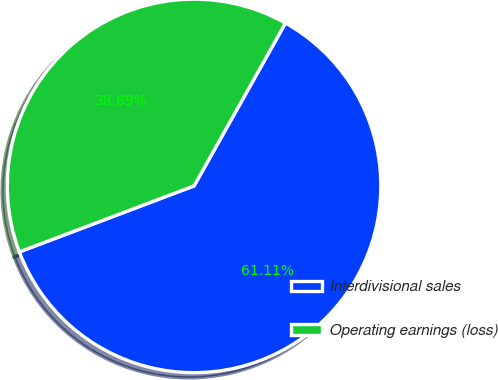Convert chart to OTSL. <chart><loc_0><loc_0><loc_500><loc_500><pie_chart><fcel>Interdivisional sales<fcel>Operating earnings (loss)<nl><fcel>61.11%<fcel>38.89%<nl></chart> 